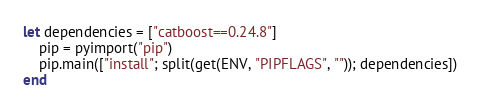<code> <loc_0><loc_0><loc_500><loc_500><_Julia_>
let dependencies = ["catboost==0.24.8"]
    pip = pyimport("pip")
    pip.main(["install"; split(get(ENV, "PIPFLAGS", "")); dependencies])
end
</code> 